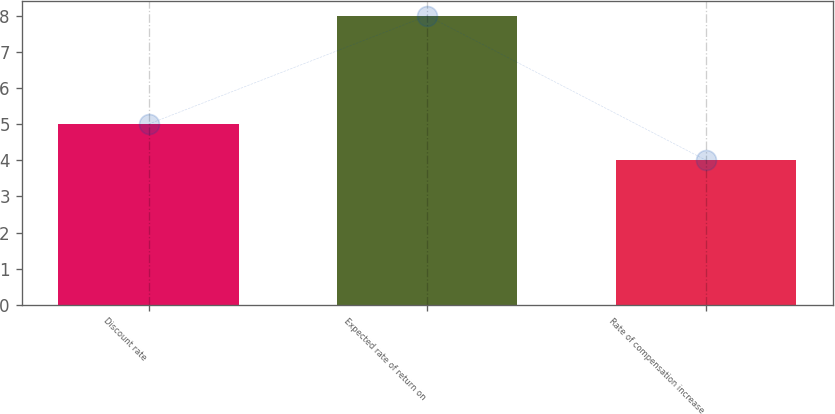Convert chart to OTSL. <chart><loc_0><loc_0><loc_500><loc_500><bar_chart><fcel>Discount rate<fcel>Expected rate of return on<fcel>Rate of compensation increase<nl><fcel>5<fcel>8<fcel>4<nl></chart> 